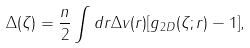<formula> <loc_0><loc_0><loc_500><loc_500>\Delta ( \zeta ) = \frac { n } { 2 } \int d { r } \Delta v ( r ) [ g _ { 2 D } ( \zeta ; r ) - 1 ] ,</formula> 